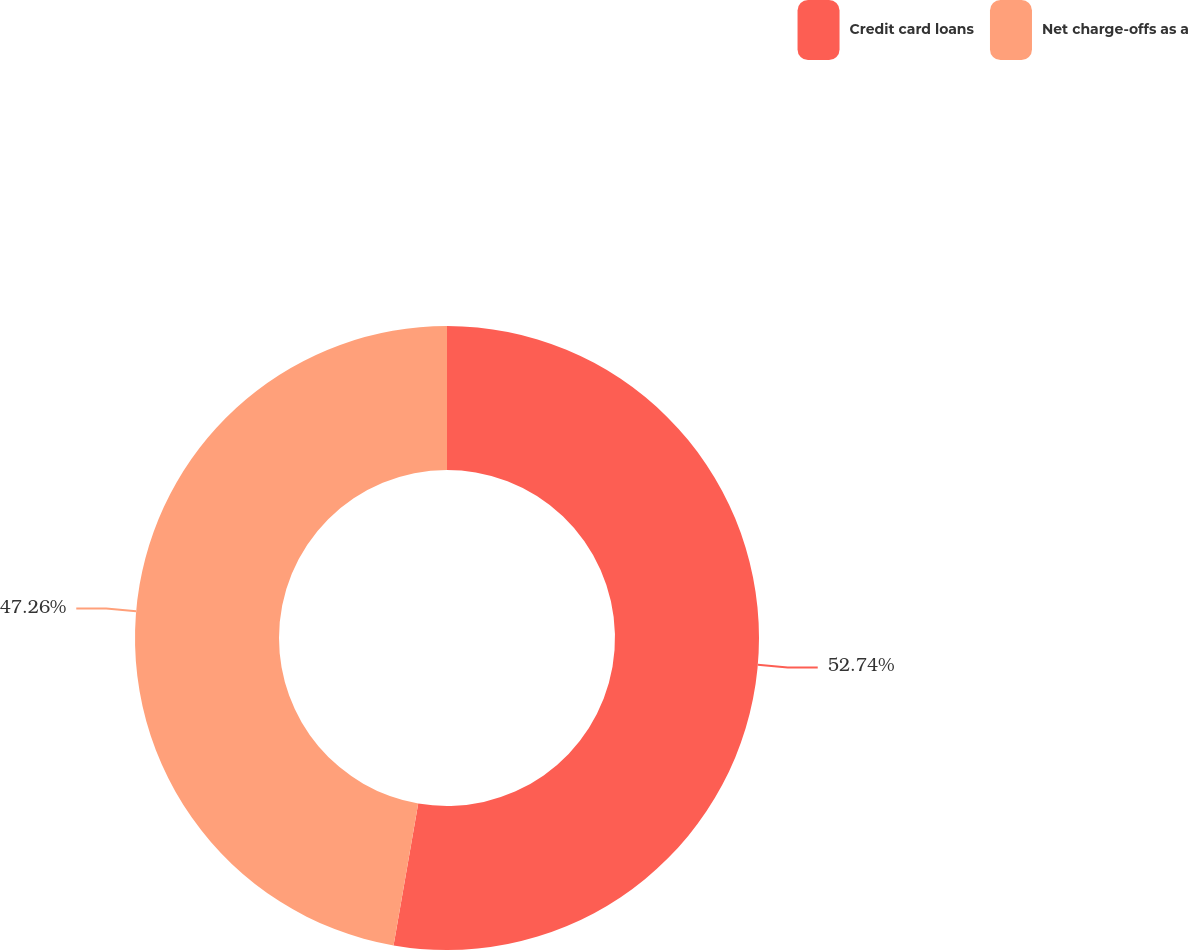Convert chart to OTSL. <chart><loc_0><loc_0><loc_500><loc_500><pie_chart><fcel>Credit card loans<fcel>Net charge-offs as a<nl><fcel>52.74%<fcel>47.26%<nl></chart> 